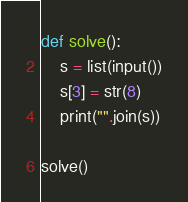<code> <loc_0><loc_0><loc_500><loc_500><_Python_>def solve():
    s = list(input())
    s[3] = str(8)
    print("".join(s))

solve()</code> 